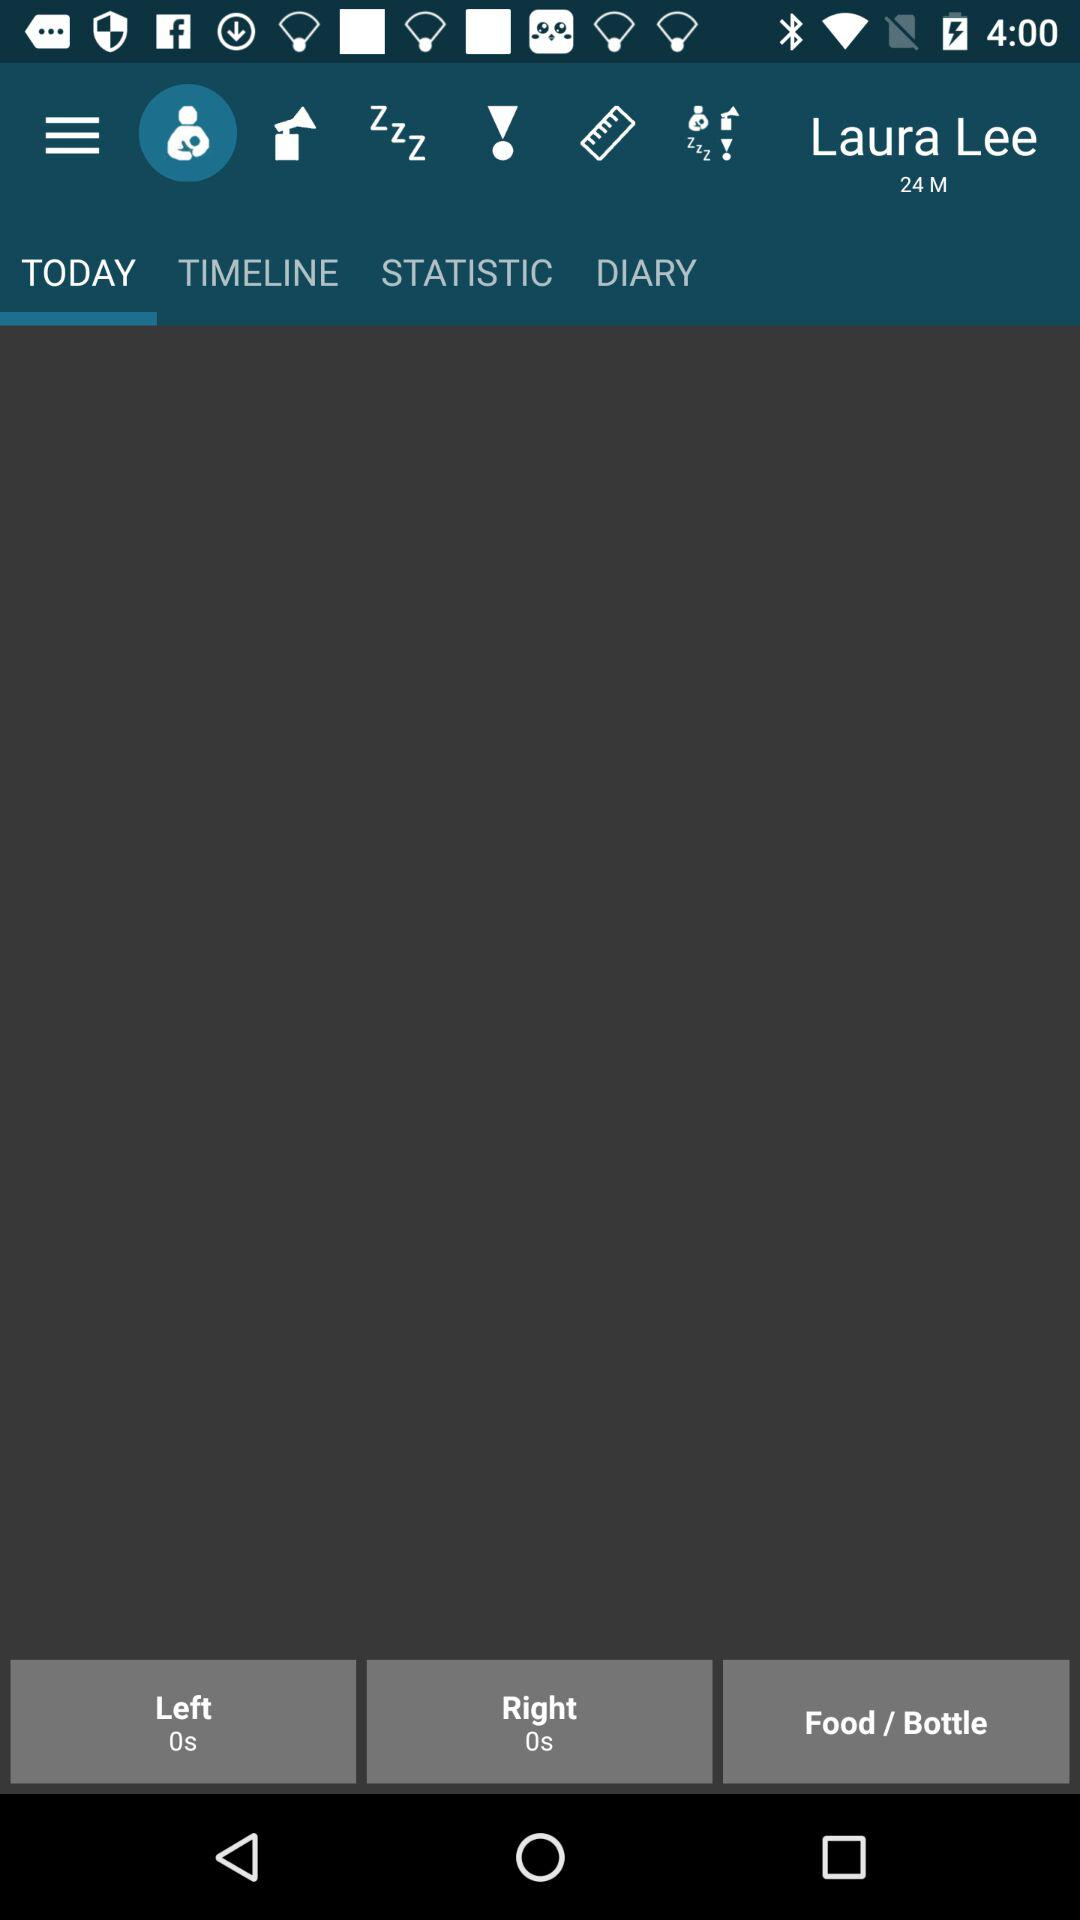What is the value of the "Right"? The value of the "Right" is 0s. 